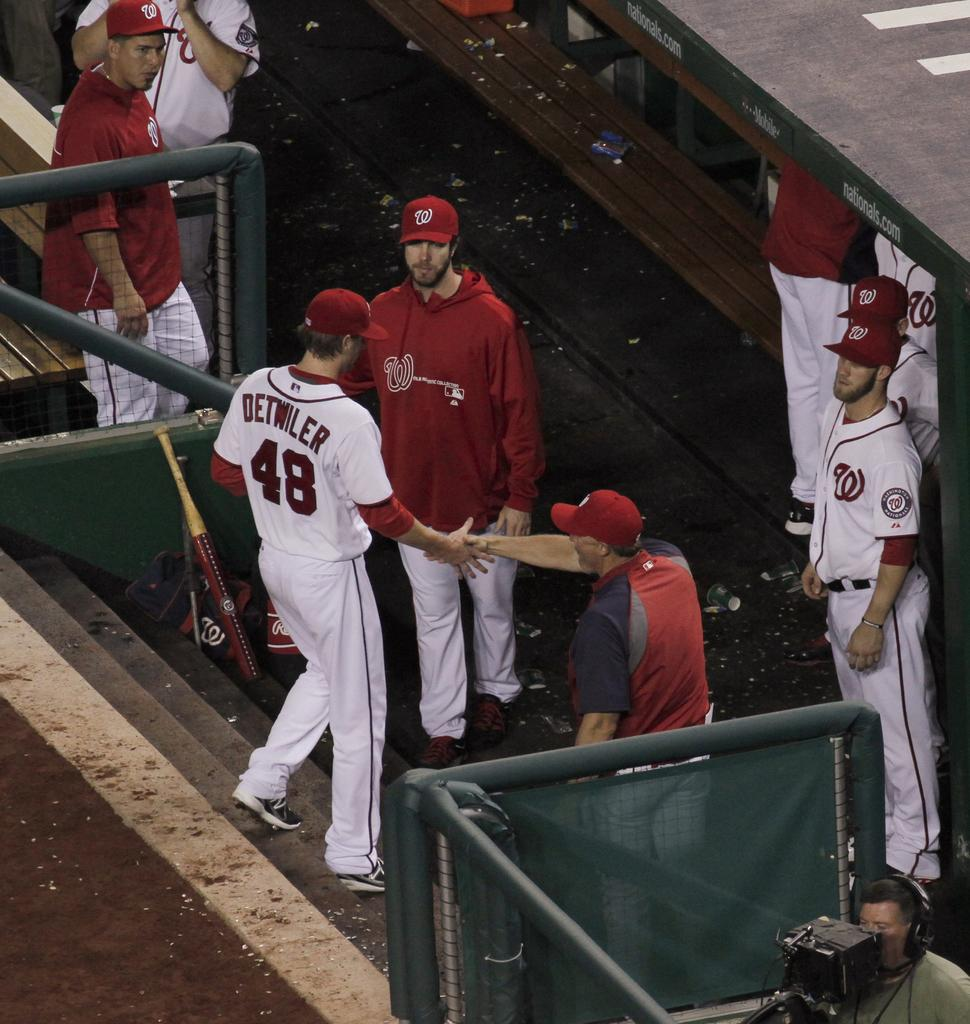Provide a one-sentence caption for the provided image. Detwiler is shaking hands with a man in a red hat as he walks down the stairs. 